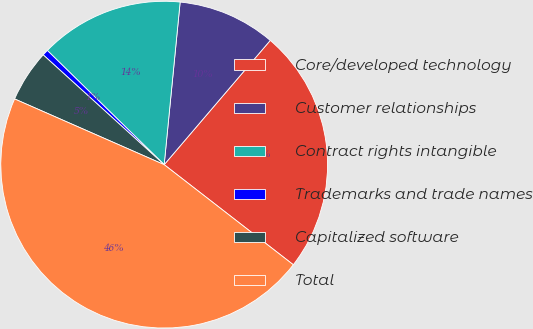Convert chart. <chart><loc_0><loc_0><loc_500><loc_500><pie_chart><fcel>Core/developed technology<fcel>Customer relationships<fcel>Contract rights intangible<fcel>Trademarks and trade names<fcel>Capitalized software<fcel>Total<nl><fcel>24.25%<fcel>9.69%<fcel>14.24%<fcel>0.59%<fcel>5.14%<fcel>46.1%<nl></chart> 